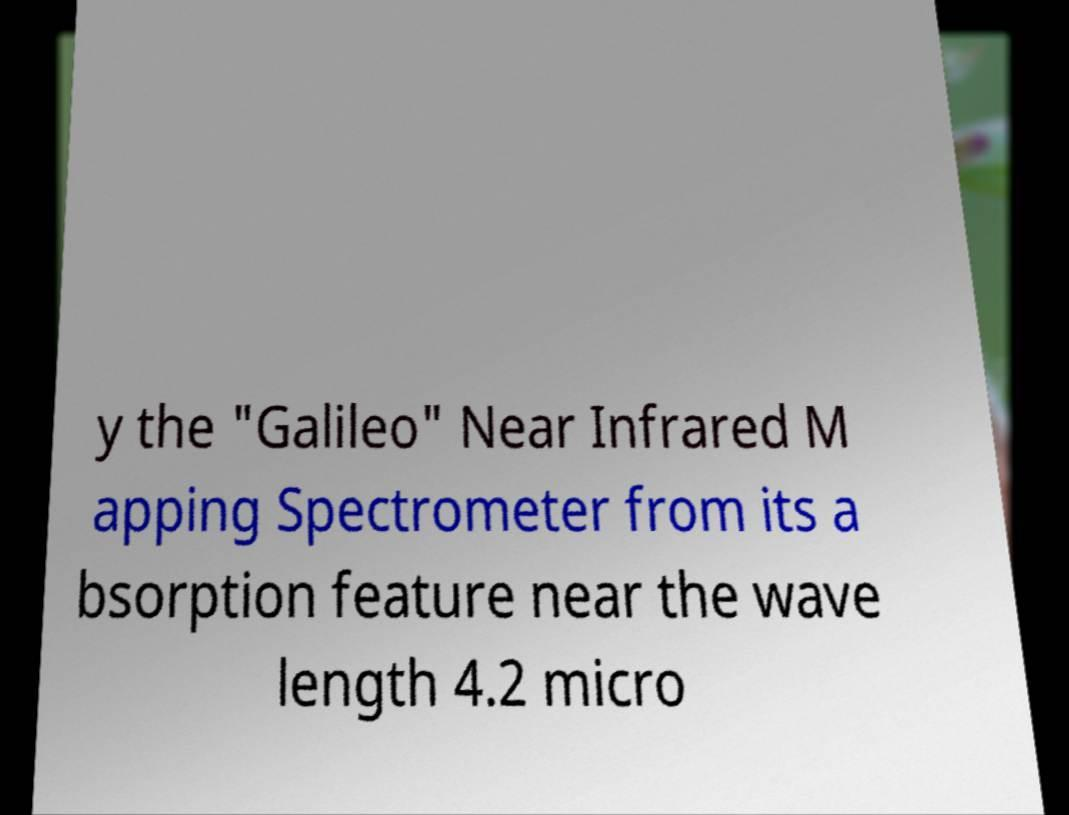Can you read and provide the text displayed in the image?This photo seems to have some interesting text. Can you extract and type it out for me? y the "Galileo" Near Infrared M apping Spectrometer from its a bsorption feature near the wave length 4.2 micro 